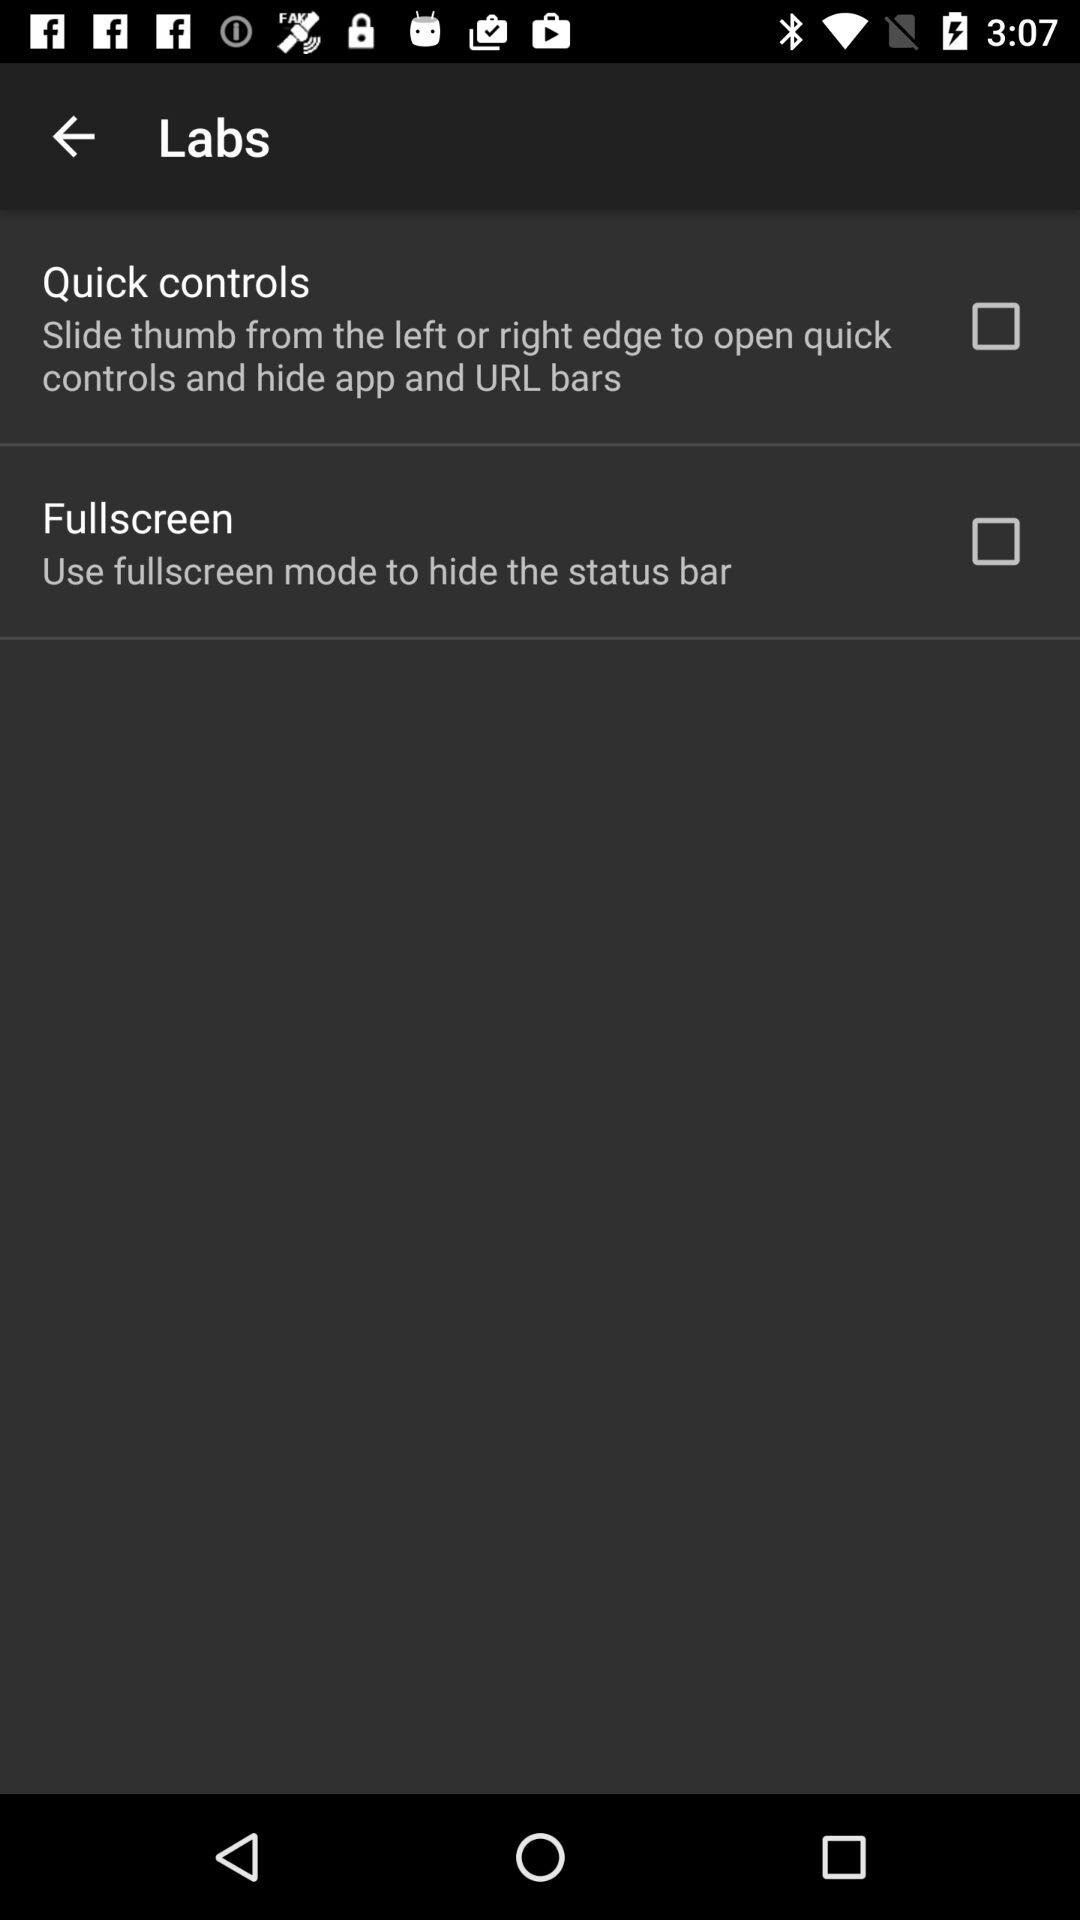What is the status of "Fullscreen"? The status is "off". 